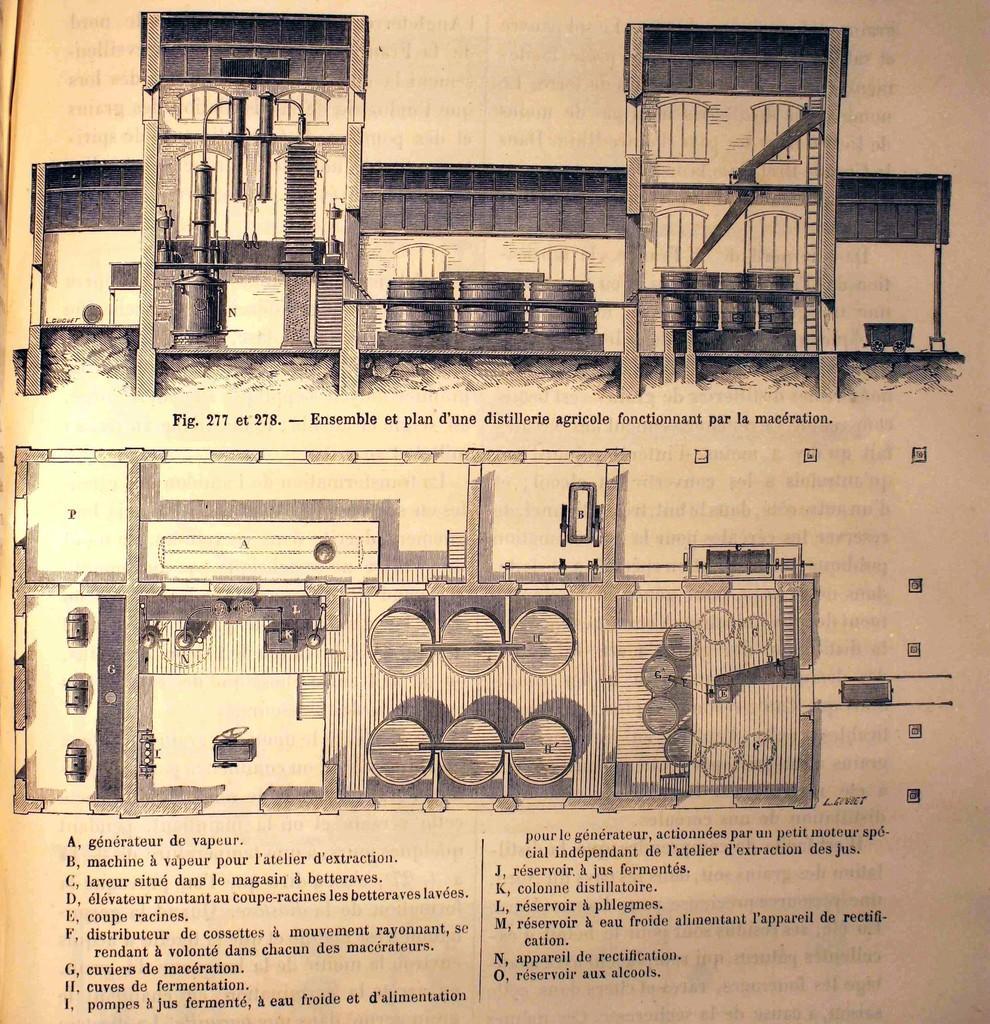Can you describe this image briefly? In the picture I can see the drawing of a machine on a white sheet paper. I can see the storage tanks and a moving trolley at the top of the image. I can see the text at the bottom of the image. 